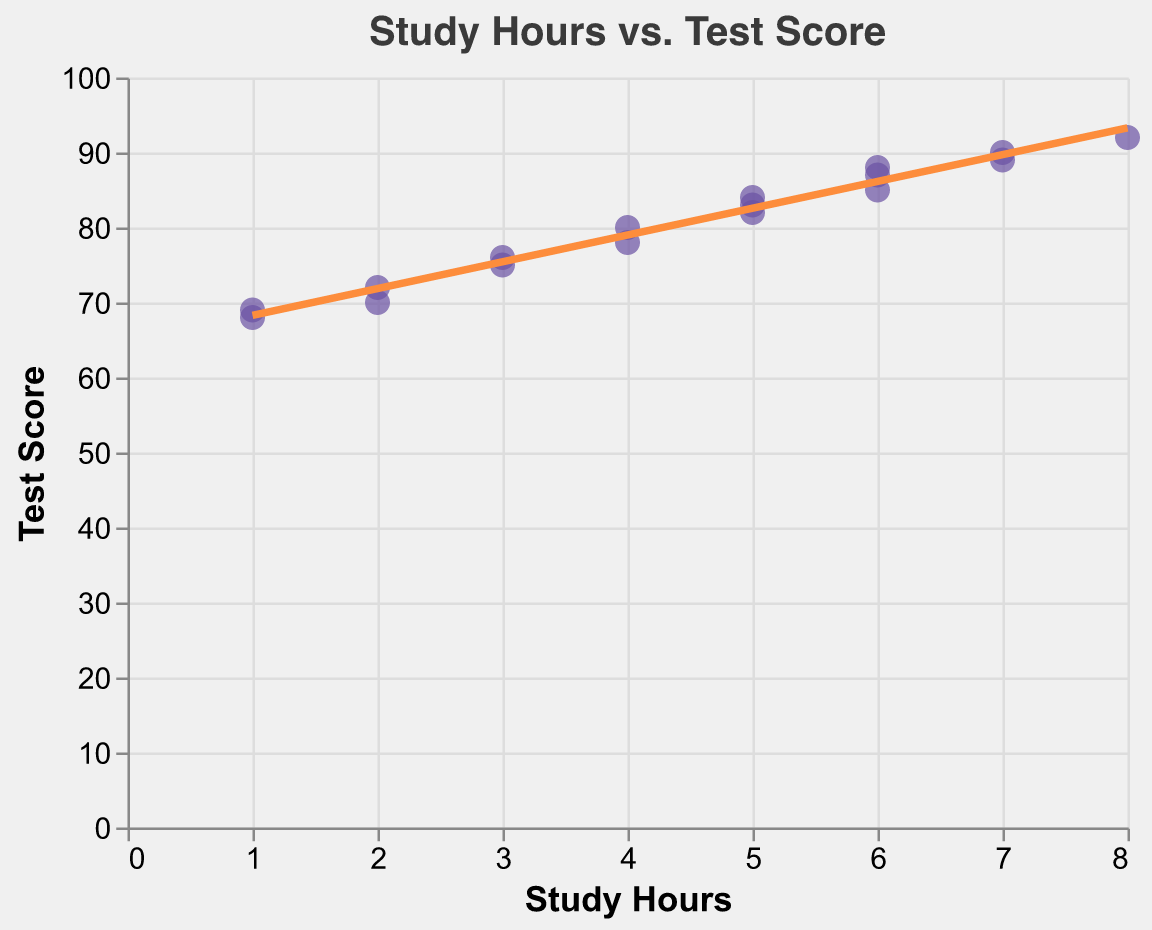What's the title of the scatter plot? The title of the scatter plot is given at the top of the figure.
Answer: Study Hours vs. Test Score How many students are represented in the scatter plot? By counting the number of data points (dots) in the scatter plot, we can determine the number of students.
Answer: 17 What is the color of the trend line? The trend line color can be observed directly from the plot.
Answer: Orange Which student has the highest test score, and what is it? By locating the highest point on the y-axis (Test Score) and checking the corresponding tooltip or label, we identify the student.
Answer: Mia Robinson, 92 How many students studied for at least 6 hours? By counting the data points with x-values (Study Hours) of 6 or greater.
Answer: 6 What is the general trend between study hours and test score as shown by the trend line? Observing the direction of the trend line indicates if it's positive or negative.
Answer: Positive What is the test score of the student who studied for 3 hours and scored closest to 75? By checking the data points' labels around the x-value of 3 and finding the one nearest to 75.
Answer: Iris Martinez, 75 Which two students have the same study hours but different test scores? By looking for clusters of data points vertically aligned (same x-value) but differing in y-value.
Answer: Bob Smith and Harry Thompson What is the difference in test scores between Mia Robinson and Olivia Lewis? Identify their test scores from the data points, then subtract Olivia's score from Mia's score.
Answer: 92 - 69 = 23 What is the average test score of students who studied exactly 5 hours? Find the test scores of all students who studied 5 hours and calculate their average. (82 + 84 + 83) / 3 = 83
Answer: 83 